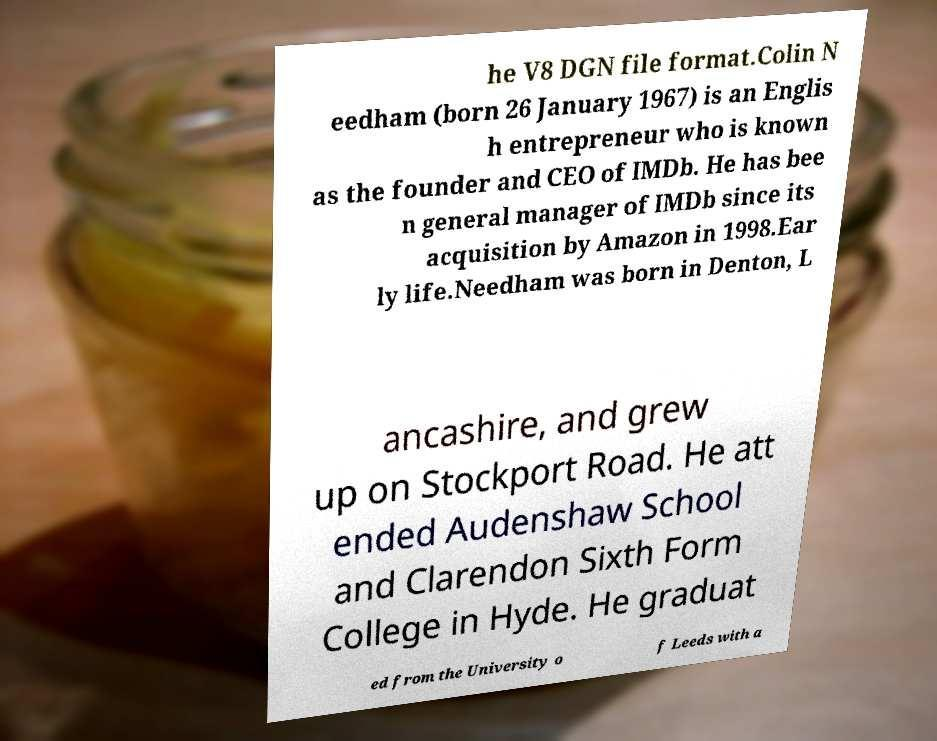For documentation purposes, I need the text within this image transcribed. Could you provide that? he V8 DGN file format.Colin N eedham (born 26 January 1967) is an Englis h entrepreneur who is known as the founder and CEO of IMDb. He has bee n general manager of IMDb since its acquisition by Amazon in 1998.Ear ly life.Needham was born in Denton, L ancashire, and grew up on Stockport Road. He att ended Audenshaw School and Clarendon Sixth Form College in Hyde. He graduat ed from the University o f Leeds with a 